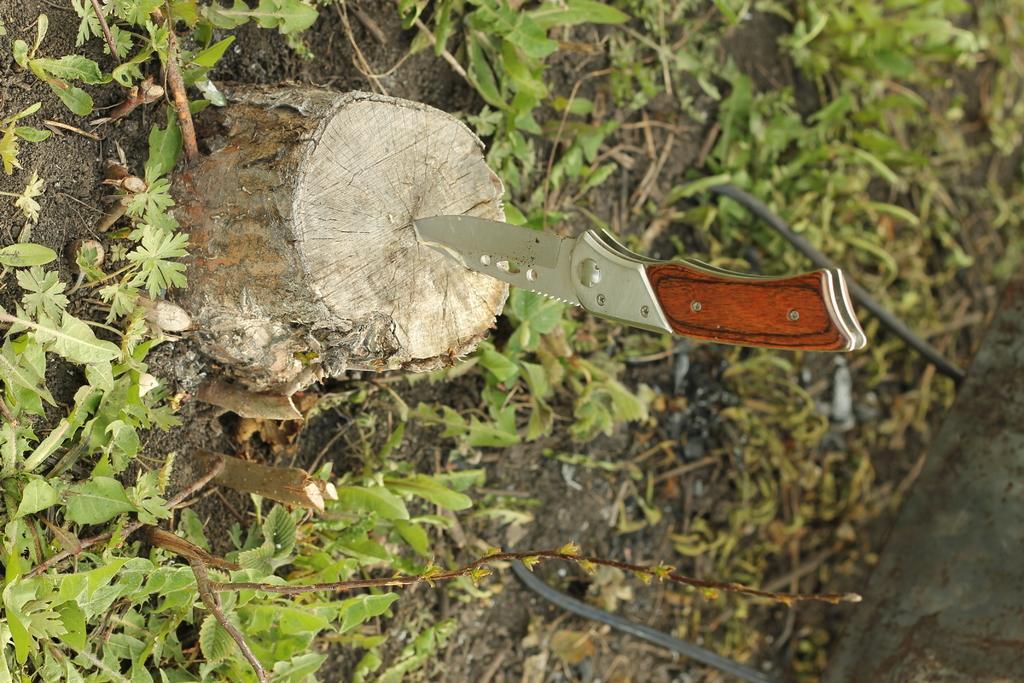Can you describe this image briefly? In this image we can see a knife penetrated into a log of wood. In the background we can see ground and plants. 